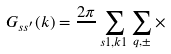Convert formula to latex. <formula><loc_0><loc_0><loc_500><loc_500>G _ { s s ^ { \prime } } ( k ) = \frac { 2 \pi } { } \sum _ { s 1 , k 1 } \sum _ { q , \pm } \times</formula> 